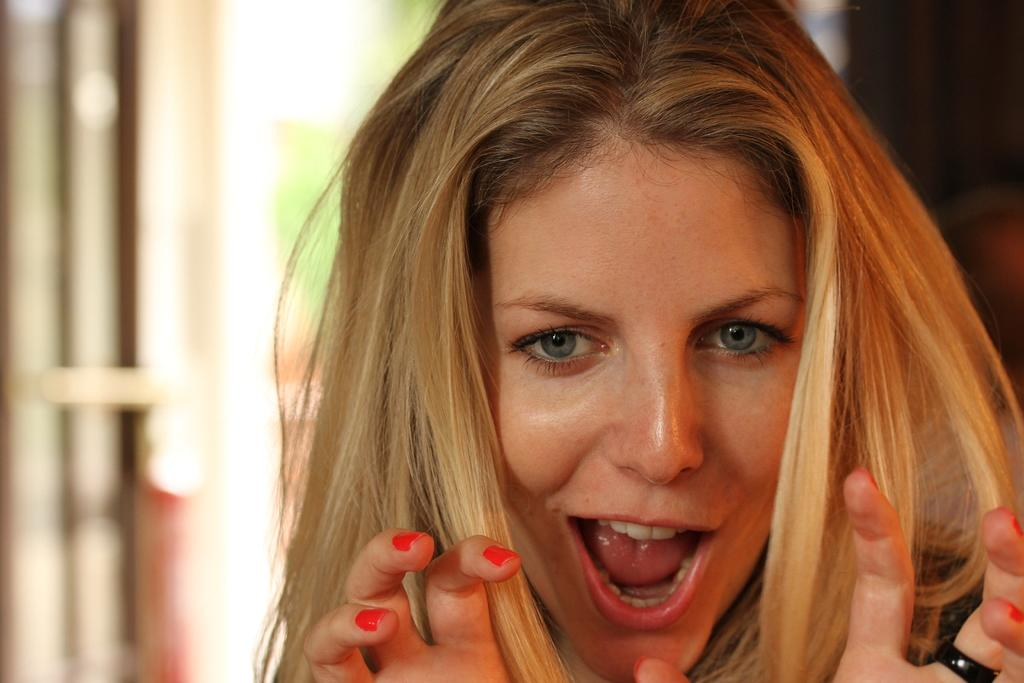Who is present in the image? There is a woman in the picture. What accessory is the woman wearing on her finger? The woman is wearing a ring on her finger. What can be seen in the background of the image? There is a window in the background of the picture. How would you describe the background of the image? The background of the picture is blurred. How many ducks are visible on the woman's head in the image? There are no ducks visible on the woman's head in the image. What type of hat is the woman wearing in the image? The woman is not wearing a hat in the image. 